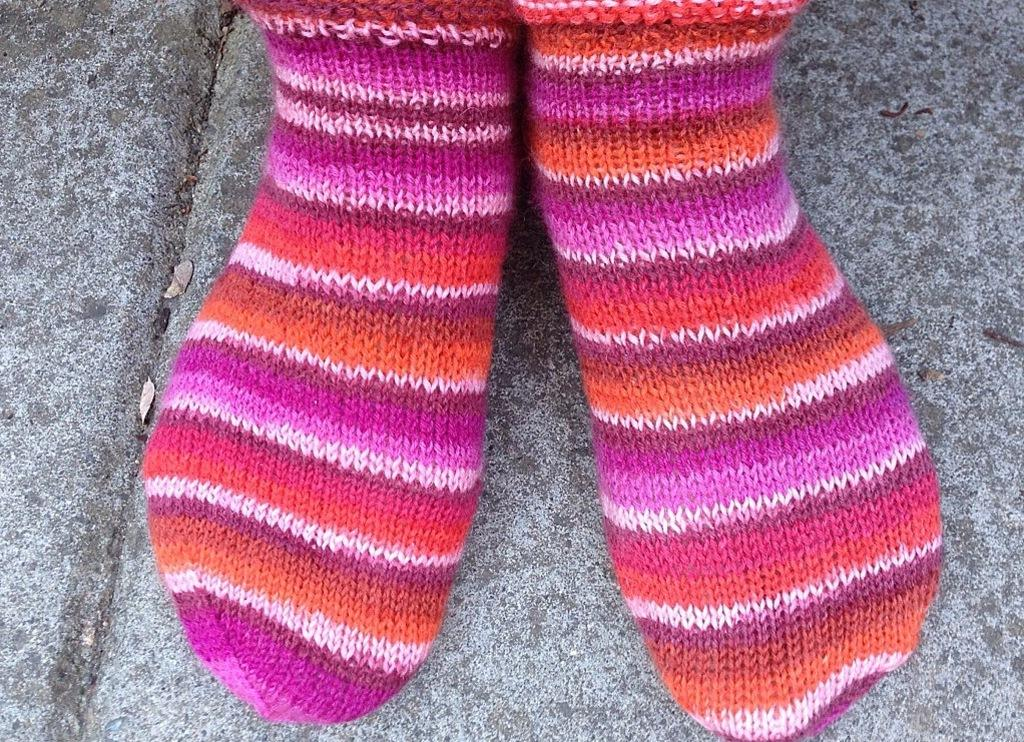What is the focus of the image? The image is zoomed in on the legs of a person. What can be seen on the person's legs? The person is wearing colorful socks. What is visible in the background of the image? The background includes the ground. Can you tell me how many donkeys are in the image? There are no donkeys present in the image. What type of care is being provided to the person in the image? The image does not show any care being provided to the person; it only shows their legs and colorful socks. 